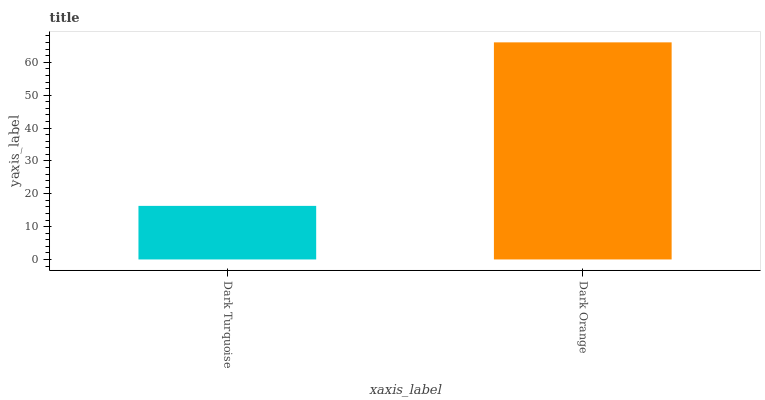Is Dark Turquoise the minimum?
Answer yes or no. Yes. Is Dark Orange the maximum?
Answer yes or no. Yes. Is Dark Orange the minimum?
Answer yes or no. No. Is Dark Orange greater than Dark Turquoise?
Answer yes or no. Yes. Is Dark Turquoise less than Dark Orange?
Answer yes or no. Yes. Is Dark Turquoise greater than Dark Orange?
Answer yes or no. No. Is Dark Orange less than Dark Turquoise?
Answer yes or no. No. Is Dark Orange the high median?
Answer yes or no. Yes. Is Dark Turquoise the low median?
Answer yes or no. Yes. Is Dark Turquoise the high median?
Answer yes or no. No. Is Dark Orange the low median?
Answer yes or no. No. 